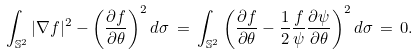<formula> <loc_0><loc_0><loc_500><loc_500>\int _ { \mathbb { S } ^ { 2 } } | \nabla f | ^ { 2 } - \left ( \frac { \partial f } { \partial \theta } \right ) ^ { 2 } d \sigma \, = \, \int _ { \mathbb { S } ^ { 2 } } \left ( \frac { \partial f } { \partial \theta } - \frac { 1 } { 2 } \frac { f } { \psi } \frac { \partial \psi } { \partial \theta } \right ) ^ { 2 } d \sigma \, = \, 0 .</formula> 